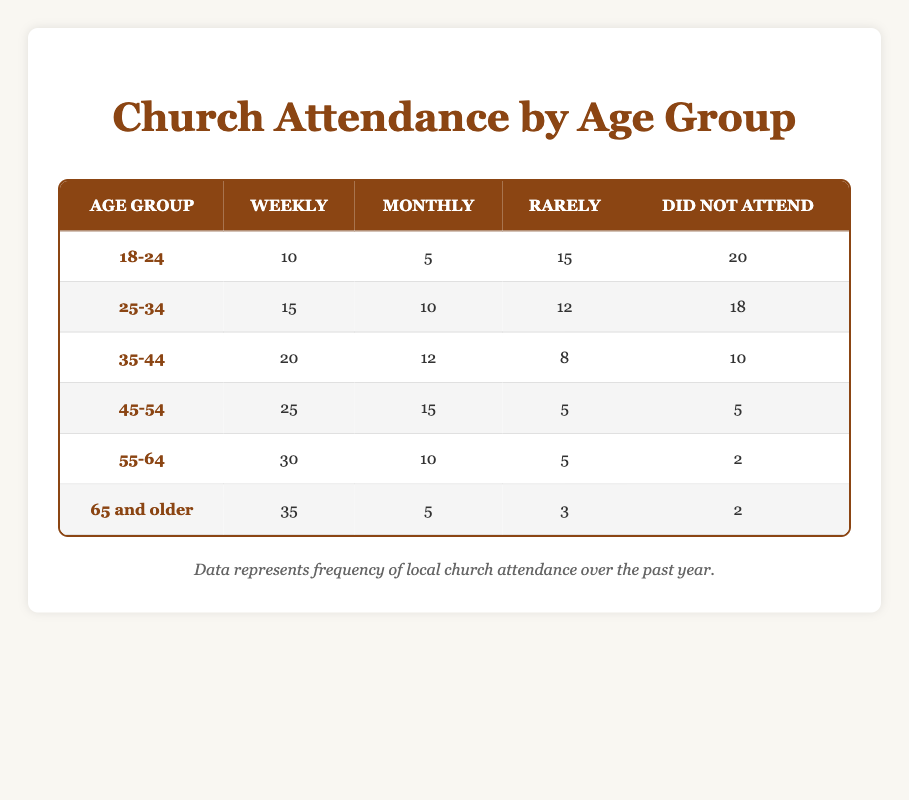What is the total number of people in the 55-64 age group who did not attend church? According to the table, the number of individuals in the 55-64 age group who did not attend is 2.
Answer: 2 Which age group had the highest number of people attending church weekly? The 65 and older age group had the highest number of weekly attendees, with 35 individuals attending weekly.
Answer: 65 and older What is the combined total of those who attended church weekly and monthly in the 45-54 age group? For the 45-54 age group, 25 attended weekly and 15 attended monthly. Combining these, we get 25 + 15 = 40.
Answer: 40 Is it true that more people in the 18-24 age group attended church weekly than those in the 35-44 age group? In the 18-24 age group, 10 attended weekly, while in the 35-44 age group, 20 attended weekly. Therefore, it is false that more 18-24-year-olds attended weekly.
Answer: No What is the average number of people who attended church weekly across all age groups? To find the average, we sum the weekly attendees: 10 + 15 + 20 + 25 + 30 + 35 = 135. Then, divide by the number of age groups (6), leading to 135 / 6 = 22.5.
Answer: 22.5 Which age group had the smallest number of people who attended church monthly? The 65 and older age group had the smallest number of monthly attendees with only 5 individuals attending monthly.
Answer: 65 and older How many more individuals in the 55-64 age group attended weekly than those who attended rarely? In the 55-64 age group, 30 attended weekly and 5 attended rarely. The difference is 30 - 5 = 25.
Answer: 25 What percentage of those aged 25-34 did not attend church? For the 25-34 age group, 18 out of 55 total attendees (15 + 10 + 12 + 18) did not attend. The percentage is calculated as (18/55) × 100 ≈ 32.73%.
Answer: 32.73% Which age group has a higher combined total of monthly and rarely attendees, 18-24 or 35-44? The 18-24 age group has 5 (monthly) + 15 (rarely) = 20, while the 35-44 age group has 12 (monthly) + 8 (rarely) = 20. Both age groups are equal in this regard.
Answer: Equal 